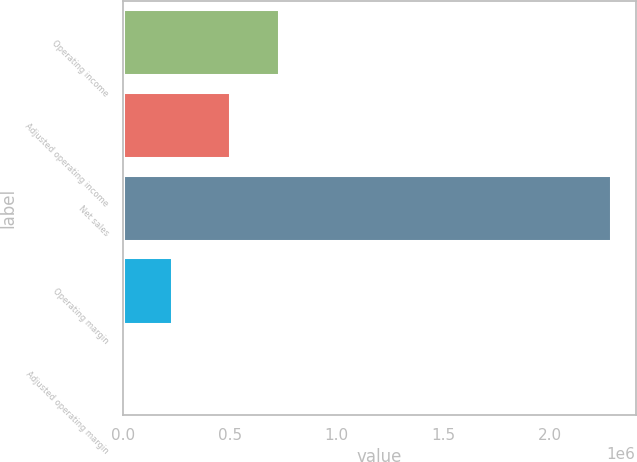Convert chart. <chart><loc_0><loc_0><loc_500><loc_500><bar_chart><fcel>Operating income<fcel>Adjusted operating income<fcel>Net sales<fcel>Operating margin<fcel>Adjusted operating margin<nl><fcel>730467<fcel>501738<fcel>2.28731e+06<fcel>228751<fcel>21.9<nl></chart> 